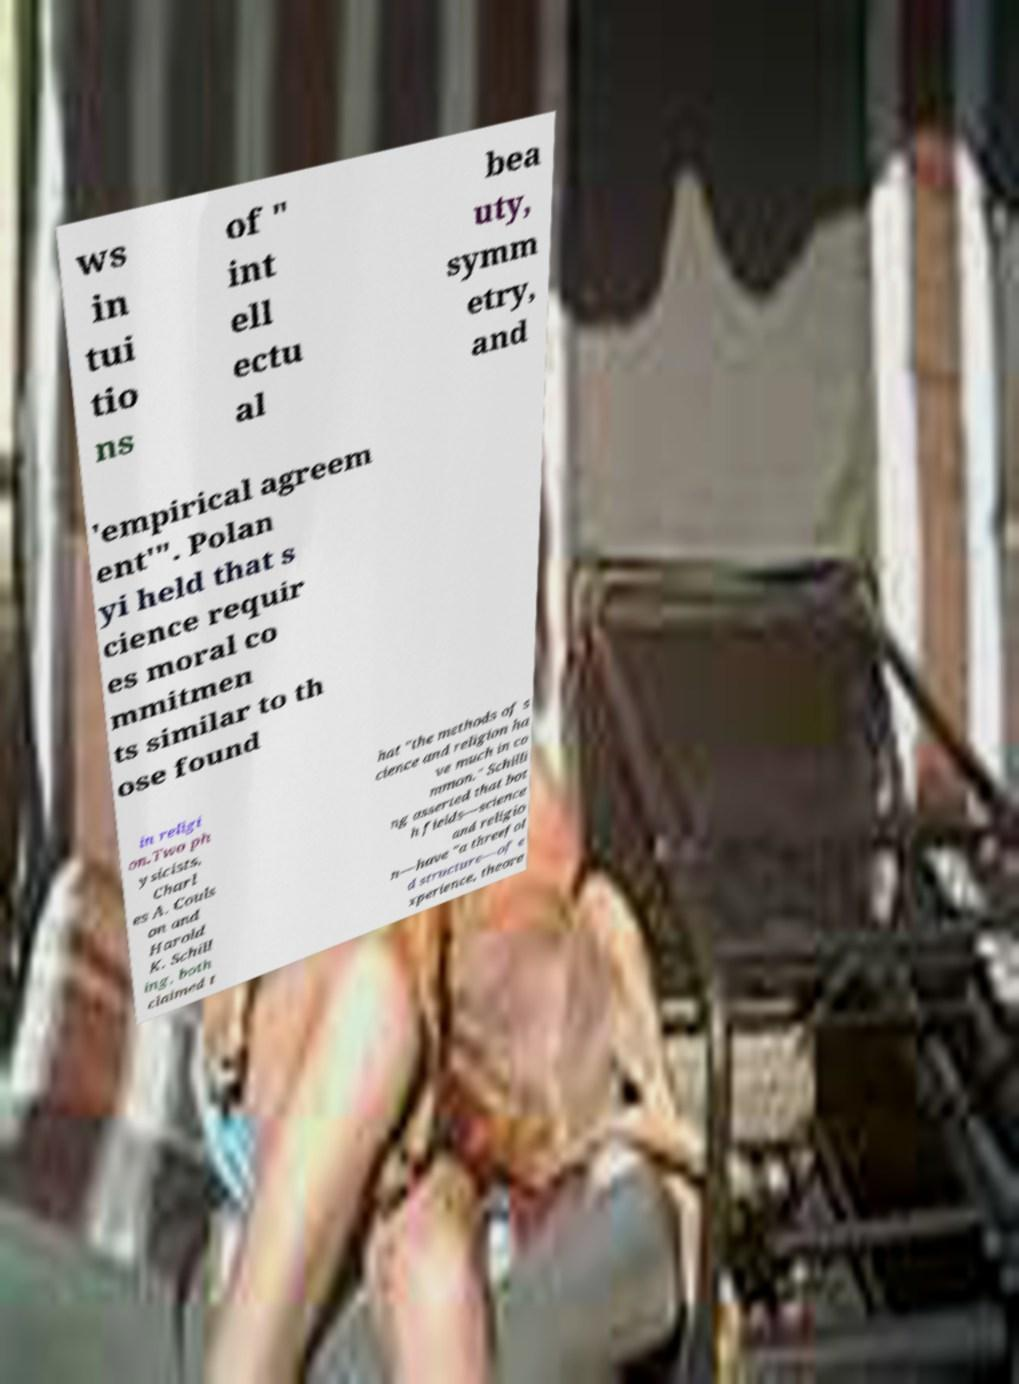Please read and relay the text visible in this image. What does it say? ws in tui tio ns of " int ell ectu al bea uty, symm etry, and 'empirical agreem ent'". Polan yi held that s cience requir es moral co mmitmen ts similar to th ose found in religi on.Two ph ysicists, Charl es A. Couls on and Harold K. Schill ing, both claimed t hat "the methods of s cience and religion ha ve much in co mmon." Schilli ng asserted that bot h fields—science and religio n—have "a threefol d structure—of e xperience, theore 